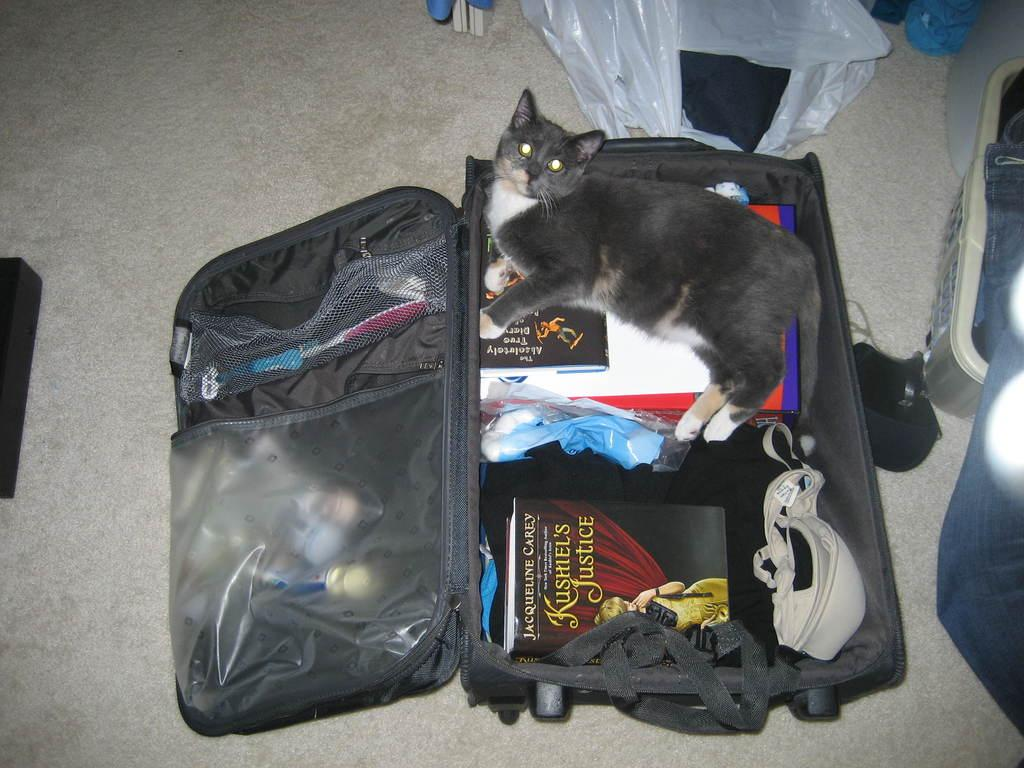What object is visible in the image that might be used for carrying belongings? There is a travel bag in the image. What items can be found inside the travel bag? Clothes, books, and a cat are present in the travel bag. What type of material is covering the objects in the image? There are covers visible in the image. What other objects are present in the image besides the travel bag? There are boxes present in the image. What type of copper stew can be seen cooking in the image? There is no copper stew present in the image; it features a travel bag with clothes, books, and a cat, along with covers and boxes. What view can be seen from the window in the image? There is no window or view present in the image; it focuses on the travel bag and its contents. 